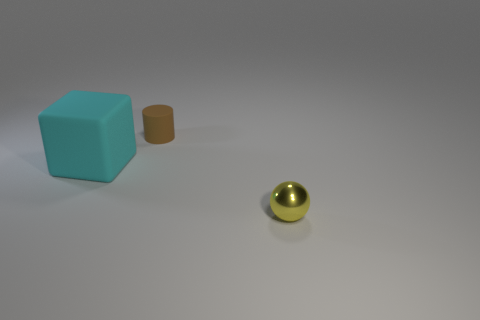There is a rubber thing left of the rubber cylinder; is its size the same as the tiny cylinder?
Keep it short and to the point. No. Is the number of cubes less than the number of objects?
Your response must be concise. Yes. Is there a large red sphere that has the same material as the large cyan cube?
Provide a succinct answer. No. What is the shape of the rubber thing that is in front of the brown cylinder?
Your answer should be very brief. Cube. Is the number of yellow balls that are to the right of the small shiny sphere less than the number of yellow metal balls?
Your answer should be very brief. Yes. There is a small cylinder that is the same material as the big block; what is its color?
Provide a short and direct response. Brown. There is a matte thing to the left of the tiny matte thing; what is its size?
Give a very brief answer. Large. Is the material of the brown thing the same as the sphere?
Offer a terse response. No. There is a large rubber object that is left of the small object that is on the left side of the yellow metallic ball; are there any objects in front of it?
Keep it short and to the point. Yes. The small matte thing has what color?
Your response must be concise. Brown. 